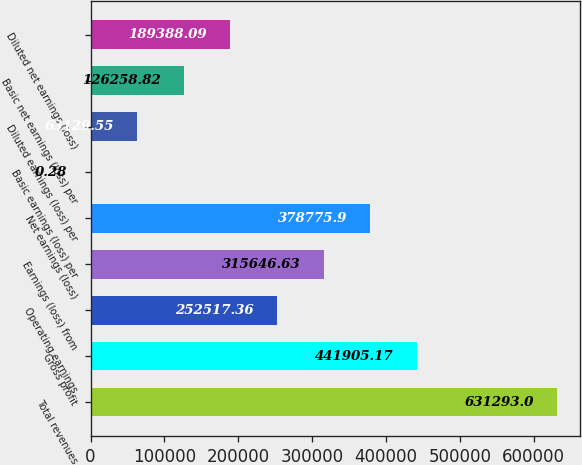Convert chart to OTSL. <chart><loc_0><loc_0><loc_500><loc_500><bar_chart><fcel>Total revenues<fcel>Gross profit<fcel>Operating earnings<fcel>Earnings (loss) from<fcel>Net earnings (loss)<fcel>Basic earnings (loss) per<fcel>Diluted earnings (loss) per<fcel>Basic net earnings (loss) per<fcel>Diluted net earnings (loss)<nl><fcel>631293<fcel>441905<fcel>252517<fcel>315647<fcel>378776<fcel>0.28<fcel>63129.6<fcel>126259<fcel>189388<nl></chart> 